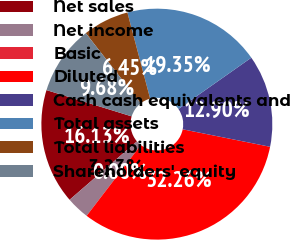<chart> <loc_0><loc_0><loc_500><loc_500><pie_chart><fcel>Net sales<fcel>Net income<fcel>Basic<fcel>Diluted<fcel>Cash cash equivalents and<fcel>Total assets<fcel>Total liabilities<fcel>Shareholders' equity<nl><fcel>16.13%<fcel>3.23%<fcel>0.0%<fcel>32.26%<fcel>12.9%<fcel>19.35%<fcel>6.45%<fcel>9.68%<nl></chart> 